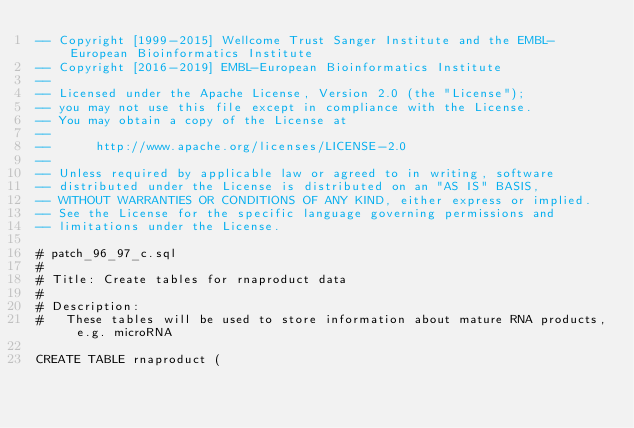<code> <loc_0><loc_0><loc_500><loc_500><_SQL_>-- Copyright [1999-2015] Wellcome Trust Sanger Institute and the EMBL-European Bioinformatics Institute
-- Copyright [2016-2019] EMBL-European Bioinformatics Institute
--
-- Licensed under the Apache License, Version 2.0 (the "License");
-- you may not use this file except in compliance with the License.
-- You may obtain a copy of the License at
--
--      http://www.apache.org/licenses/LICENSE-2.0
--
-- Unless required by applicable law or agreed to in writing, software
-- distributed under the License is distributed on an "AS IS" BASIS,
-- WITHOUT WARRANTIES OR CONDITIONS OF ANY KIND, either express or implied.
-- See the License for the specific language governing permissions and
-- limitations under the License.

# patch_96_97_c.sql
#
# Title: Create tables for rnaproduct data
#
# Description:
#   These tables will be used to store information about mature RNA products, e.g. microRNA

CREATE TABLE rnaproduct (
</code> 